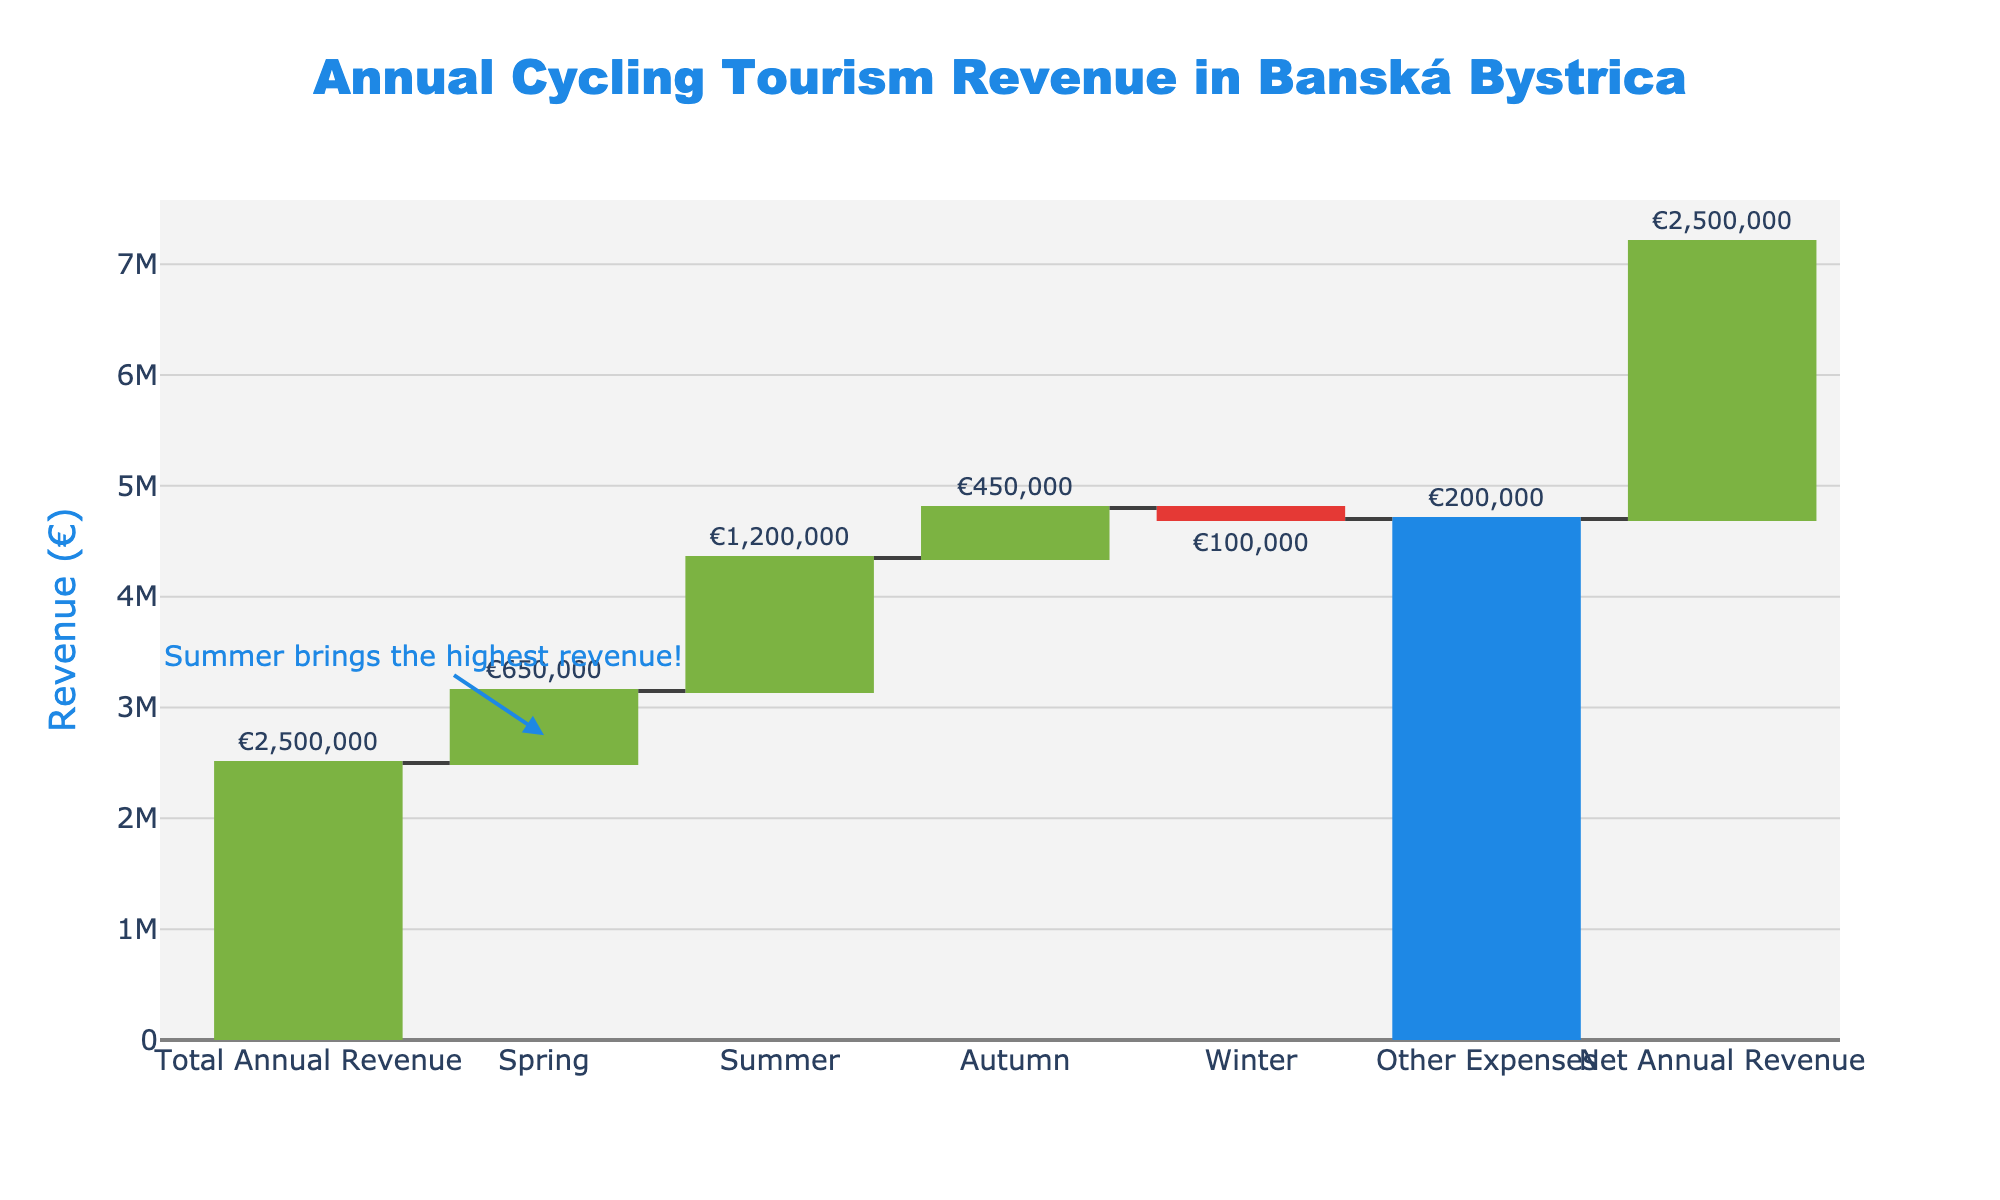What is the total annual revenue for cycling tourism in Banská Bystrica? The total annual revenue can be found from the data labeled "Total Annual Revenue." This label shows a value of €2,500,000
Answer: €2,500,000 Which season contributes the most to the annual cycling tourism revenue? To find the season with the highest contribution, look at the values for each season in the waterfall chart. Summer has the highest value at €1,200,000
Answer: Summer What is the net annual revenue after accounting for expenses? The net annual revenue can be read directly from the waterfall chart entry labeled "Net Annual Revenue," which shows a value of €2,500,000
Answer: €2,500,000 How much does winter reduce the annual cycling tourism revenue? Winter contribution is shown as -€100,000, indicating a reduction of €100,000
Answer: €100,000 What is the combined revenue of spring and autumn? Spring revenue is €650,000 and autumn revenue is €450,000. The combined revenue is €650,000 + €450,000 = €1,100,000
Answer: €1,100,000 By how much do other expenses reduce the total annual revenue? Other expenses are shown as -€200,000 on the chart, indicating they reduce the total revenue by €200,000
Answer: €200,000 Which season has the lowest positive revenue contribution? Among the seasons with positive contributions, autumn has the lowest value at €450,000
Answer: Autumn How much higher is the summer revenue compared to the spring revenue? Summer revenue is €1,200,000, and spring revenue is €650,000. The difference is €1,200,000 - €650,000 = €550,000
Answer: €550,000 What is the average revenue per season, excluding winter? Summing spring, summer, and autumn gives €650,000 + €1,200,000 + €450,000 = €2,300,000. The average is €2,300,000 / 3 = €766,667
Answer: €766,667 What is the overall change in revenue due to all seasons combined? Spring, summer, and autumn contributions are €650,000, €1,200,000, and €450,000, respectively. Winter contributes -€100,000. The overall change is €650,000 + €1,200,000 + €450,000 - €100,000 = €2,200,000
Answer: €2,200,000 